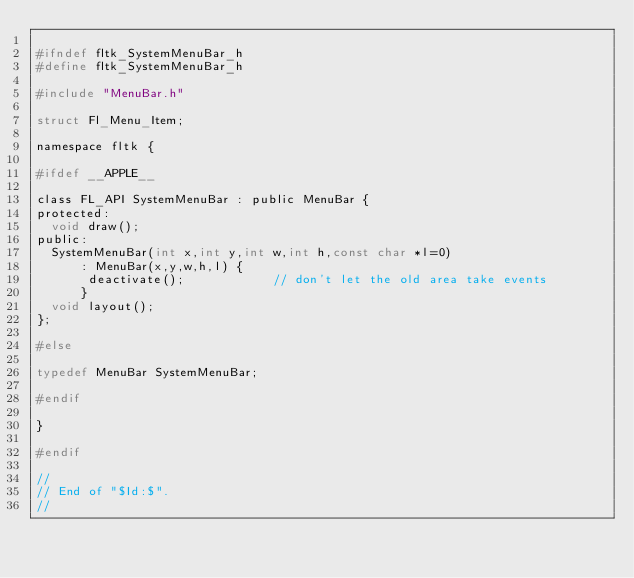<code> <loc_0><loc_0><loc_500><loc_500><_C_>
#ifndef fltk_SystemMenuBar_h
#define fltk_SystemMenuBar_h 

#include "MenuBar.h"

struct Fl_Menu_Item;

namespace fltk {

#ifdef __APPLE__

class FL_API SystemMenuBar : public MenuBar {
protected:
  void draw();
public:
  SystemMenuBar(int x,int y,int w,int h,const char *l=0)
      : MenuBar(x,y,w,h,l) {
	   deactivate();			// don't let the old area take events
	  }
  void layout();
};

#else

typedef MenuBar SystemMenuBar;

#endif

}

#endif

//
// End of "$Id:$".
//
</code> 